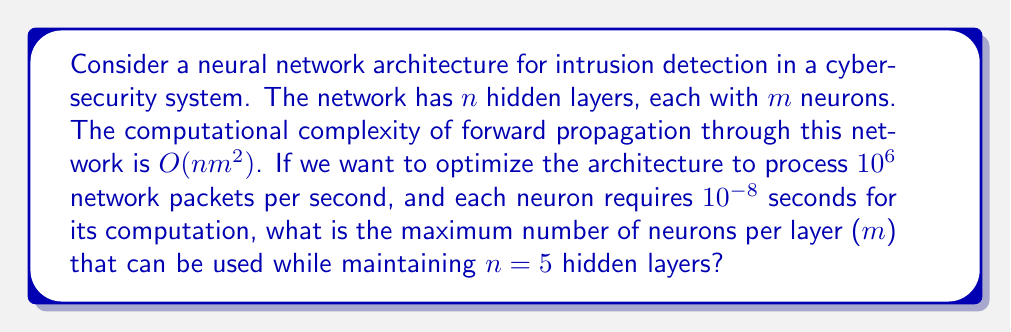Could you help me with this problem? Let's approach this step-by-step:

1) The computational complexity is $O(nm^2)$, which means the time taken is proportional to $nm^2$.

2) Each neuron takes $10^{-8}$ seconds for its computation.

3) The total time for one forward pass through the network is:

   $$T = knm^2 \cdot 10^{-8}$$

   where $k$ is some constant of proportionality.

4) We need to process $10^6$ packets per second, so the time for one forward pass must be at most $10^{-6}$ seconds:

   $$knm^2 \cdot 10^{-8} \leq 10^{-6}$$

5) We're given that $n=5$, so:

   $$k \cdot 5m^2 \cdot 10^{-8} \leq 10^{-6}$$

6) Simplifying:

   $$5km^2 \leq 100$$

7) The constant $k$ is unknown, but in the worst case (largest possible $m$), it would be 1. So we can write:

   $$5m^2 \leq 100$$

8) Solving for $m$:

   $$m^2 \leq 20$$
   $$m \leq \sqrt{20} \approx 4.47$$

9) Since $m$ must be an integer, we round down to ensure we meet the time constraint.
Answer: The maximum number of neurons per layer ($m$) that can be used while maintaining $n=5$ hidden layers is 4. 